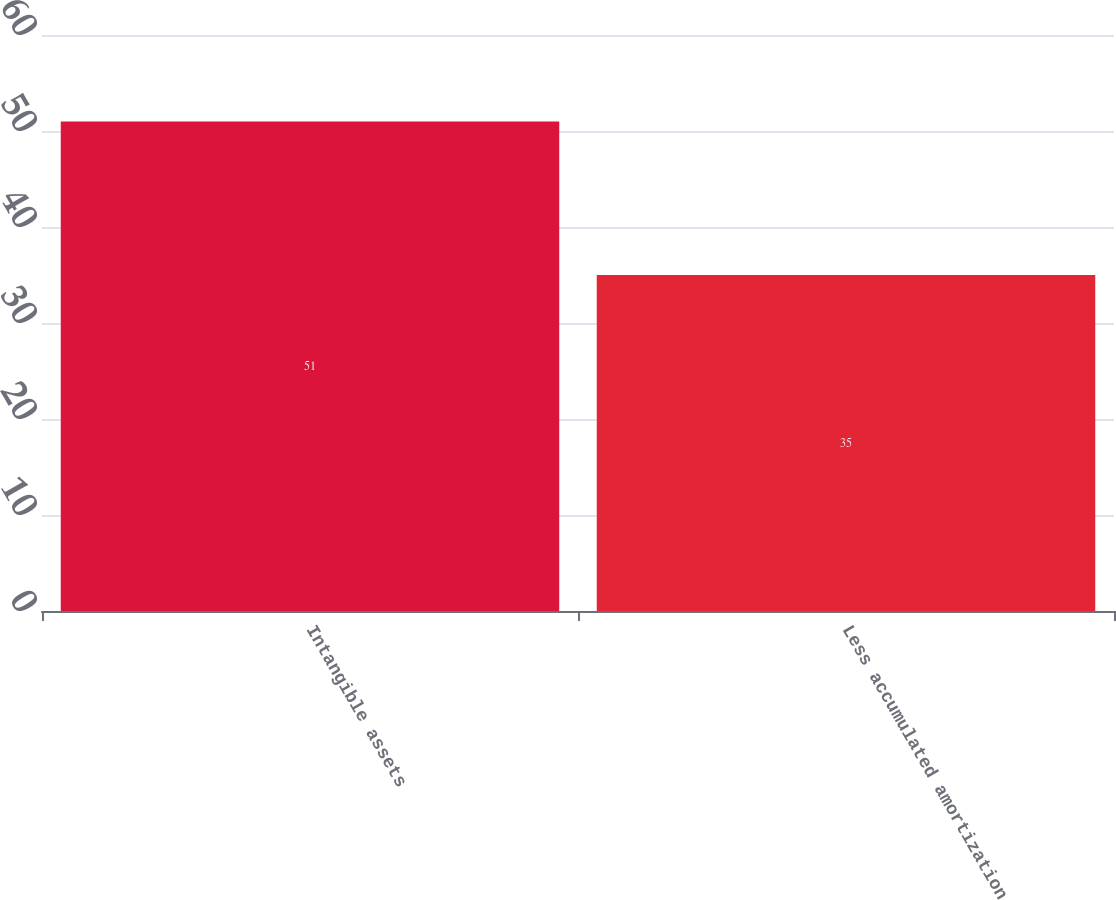Convert chart. <chart><loc_0><loc_0><loc_500><loc_500><bar_chart><fcel>Intangible assets<fcel>Less accumulated amortization<nl><fcel>51<fcel>35<nl></chart> 